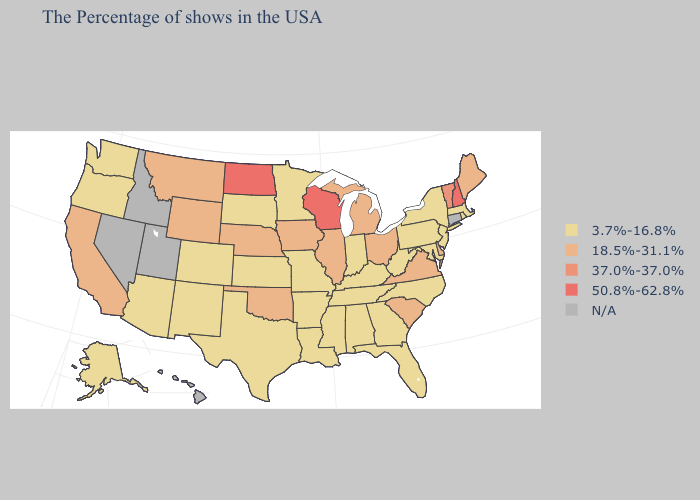What is the highest value in the USA?
Be succinct. 50.8%-62.8%. Which states have the lowest value in the Northeast?
Short answer required. Massachusetts, Rhode Island, New York, New Jersey, Pennsylvania. What is the highest value in the South ?
Short answer required. 18.5%-31.1%. Name the states that have a value in the range 50.8%-62.8%?
Keep it brief. New Hampshire, Wisconsin, North Dakota. What is the highest value in the USA?
Keep it brief. 50.8%-62.8%. Which states hav the highest value in the MidWest?
Give a very brief answer. Wisconsin, North Dakota. What is the value of Maine?
Quick response, please. 18.5%-31.1%. How many symbols are there in the legend?
Give a very brief answer. 5. How many symbols are there in the legend?
Short answer required. 5. Name the states that have a value in the range 3.7%-16.8%?
Give a very brief answer. Massachusetts, Rhode Island, New York, New Jersey, Maryland, Pennsylvania, North Carolina, West Virginia, Florida, Georgia, Kentucky, Indiana, Alabama, Tennessee, Mississippi, Louisiana, Missouri, Arkansas, Minnesota, Kansas, Texas, South Dakota, Colorado, New Mexico, Arizona, Washington, Oregon, Alaska. What is the highest value in the MidWest ?
Quick response, please. 50.8%-62.8%. Does Rhode Island have the highest value in the USA?
Be succinct. No. Does the first symbol in the legend represent the smallest category?
Concise answer only. Yes. Name the states that have a value in the range 18.5%-31.1%?
Quick response, please. Maine, Delaware, Virginia, South Carolina, Ohio, Michigan, Illinois, Iowa, Nebraska, Oklahoma, Wyoming, Montana, California. 